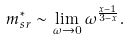<formula> <loc_0><loc_0><loc_500><loc_500>m ^ { * } _ { s r } \sim \lim _ { \omega \to 0 } \omega ^ { \frac { x - 1 } { 3 - x } } .</formula> 